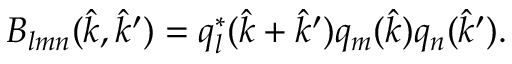<formula> <loc_0><loc_0><loc_500><loc_500>B _ { l m n } ( \hat { k } , \hat { k } ^ { \prime } ) = q _ { l } ^ { * } ( \hat { k } + \hat { k } ^ { \prime } ) q _ { m } ( \hat { k } ) q _ { n } ( \hat { k } ^ { \prime } ) .</formula> 